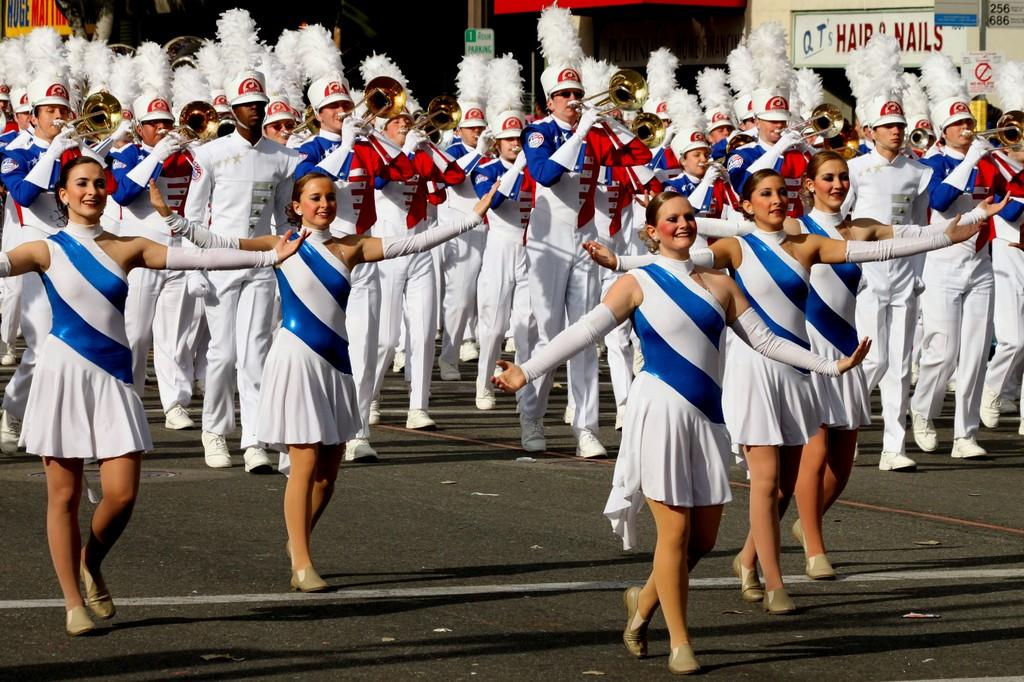<image>
Give a short and clear explanation of the subsequent image. A band is marching down the street in white and blue uniforms past a store called Q.T.'s Hair and Nails. 